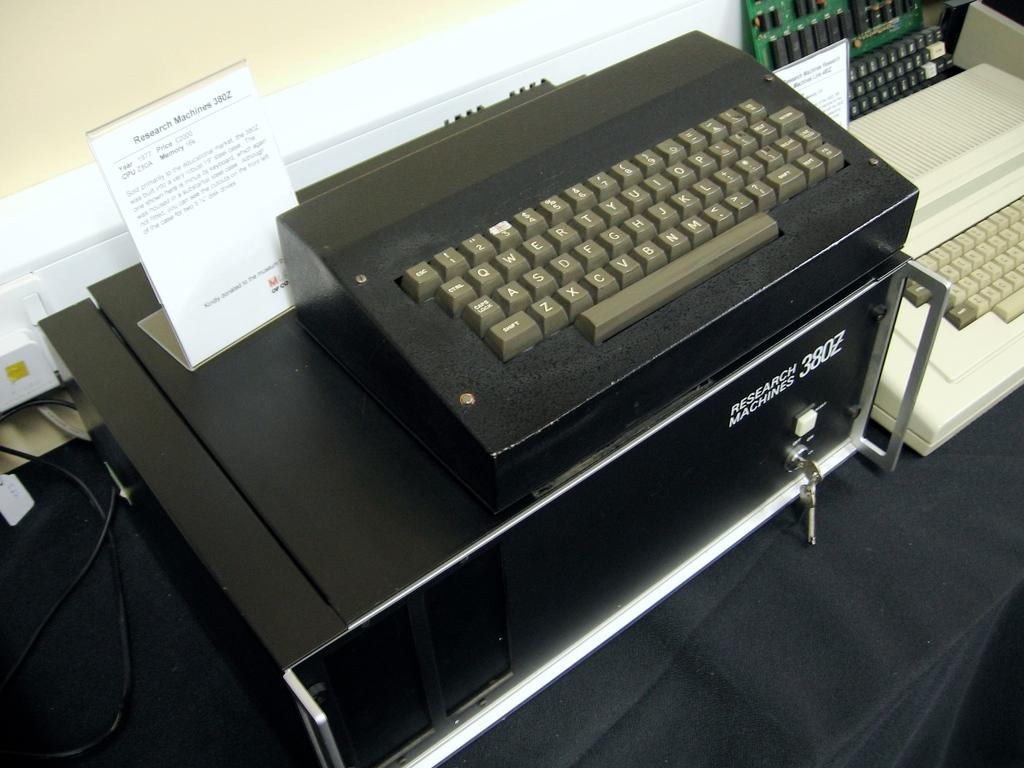What price is listed on the sign?
Ensure brevity in your answer.  Unanswerable. What number is on the black box below the keyboard?
Your response must be concise. 3802. 